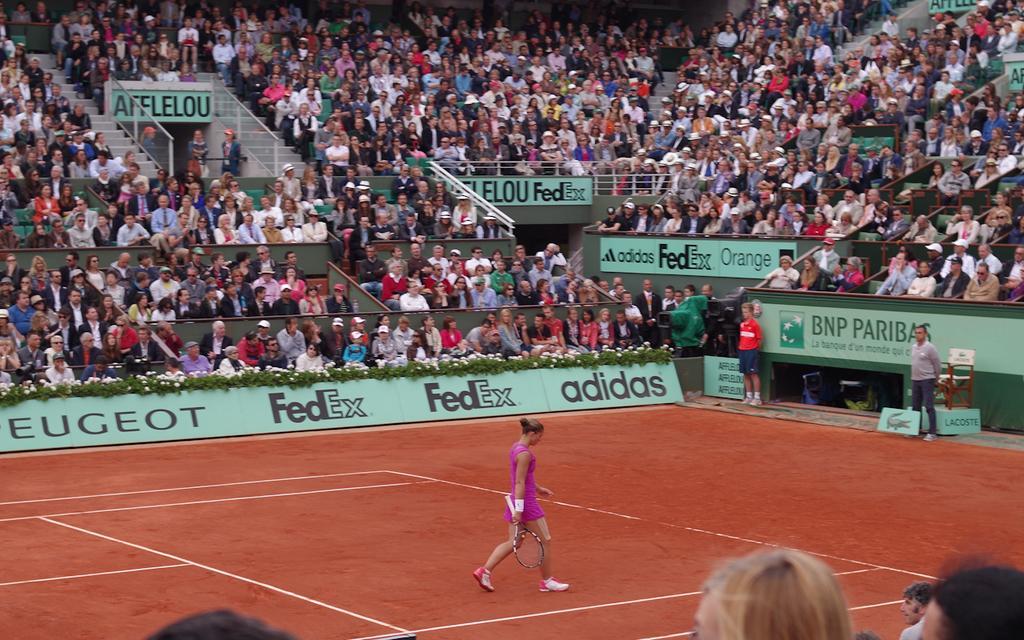In one or two sentences, can you explain what this image depicts? This image is taken in a stadium. In the center there is a woman walking holding a bat in her hand. In the background there are persons sitting and standing and there are banners with some text written on it. 